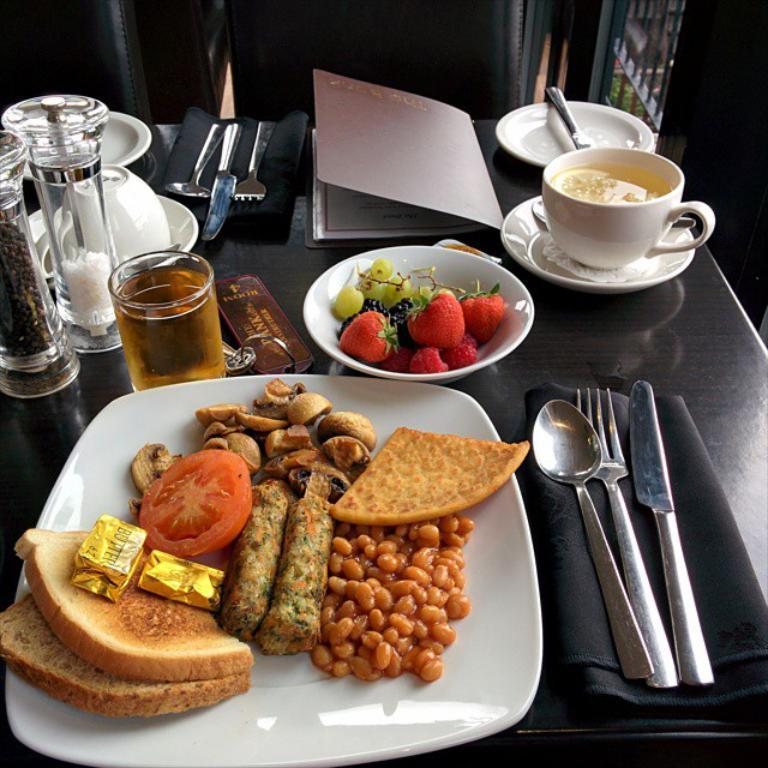What is on the plate in the image? There is food on a plate in the image. What type of food can be seen on the plate? The provided facts do not specify the type of food on the plate. What other items are visible in the image besides the plate? There are fruits, a cup, a saucer, a knife, a fork, a spoon, a napkin, a beverage in a glass, and all of these items are placed on a table. How many utensils are present in the image? There are three utensils in the image: a knife, a fork, and a spoon. What type of rail is visible in the image? There is no rail present in the image. How many clocks can be seen on the table in the image? There are no clocks visible in the image. 